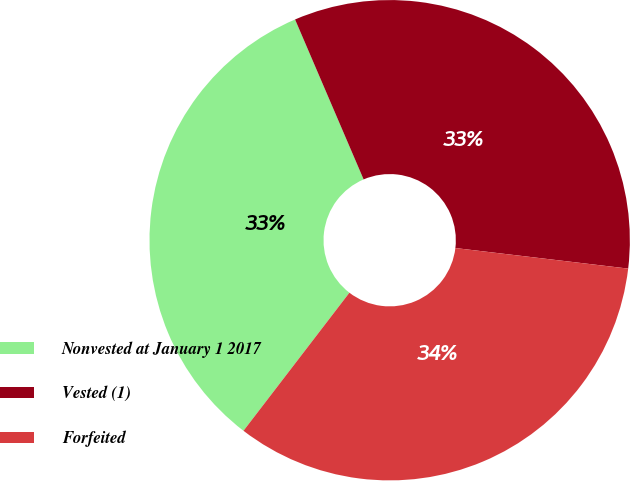Convert chart. <chart><loc_0><loc_0><loc_500><loc_500><pie_chart><fcel>Nonvested at January 1 2017<fcel>Vested (1)<fcel>Forfeited<nl><fcel>33.14%<fcel>33.33%<fcel>33.53%<nl></chart> 